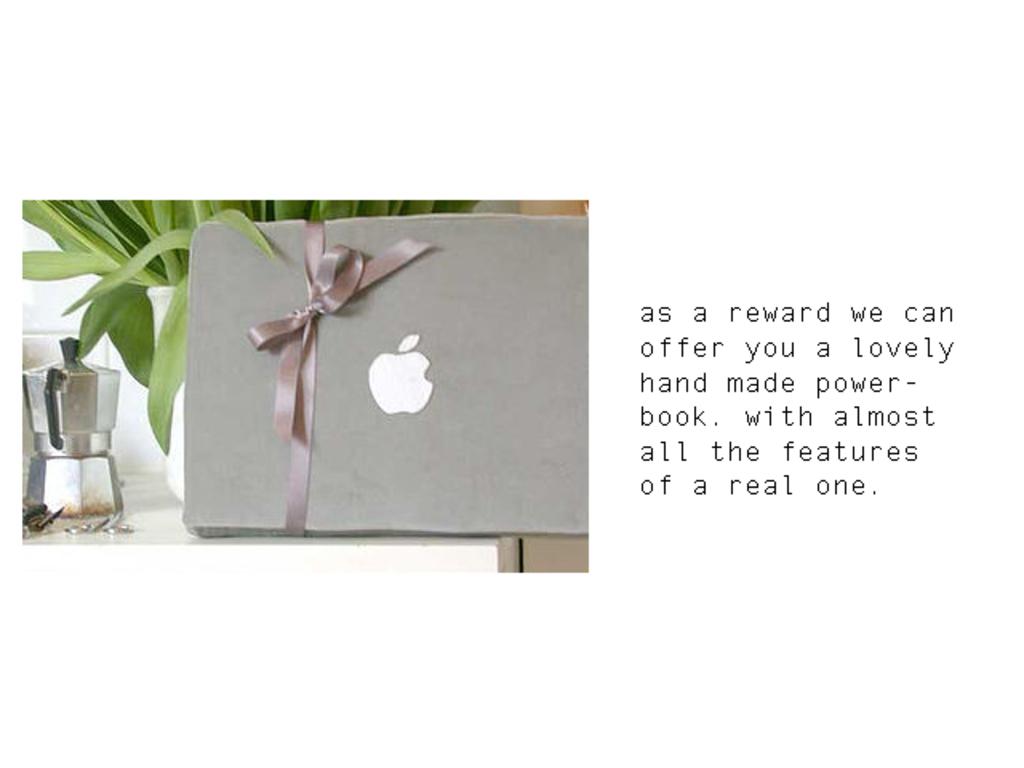What is the reward?
Your response must be concise. Hand made power-book. 